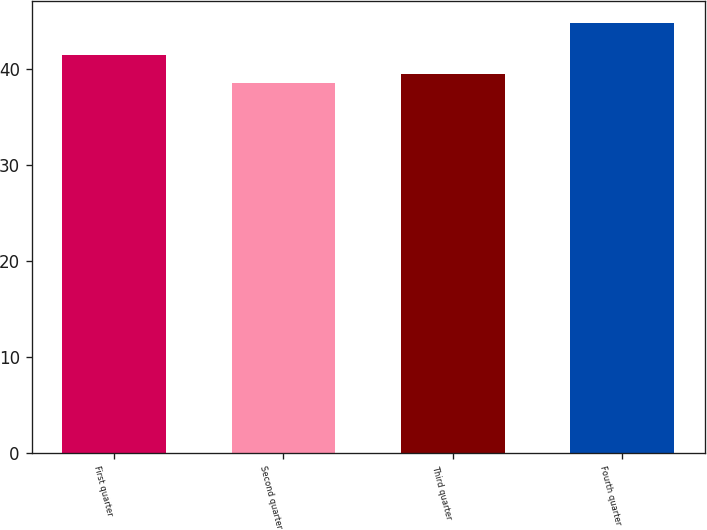<chart> <loc_0><loc_0><loc_500><loc_500><bar_chart><fcel>First quarter<fcel>Second quarter<fcel>Third quarter<fcel>Fourth quarter<nl><fcel>41.42<fcel>38.53<fcel>39.44<fcel>44.75<nl></chart> 